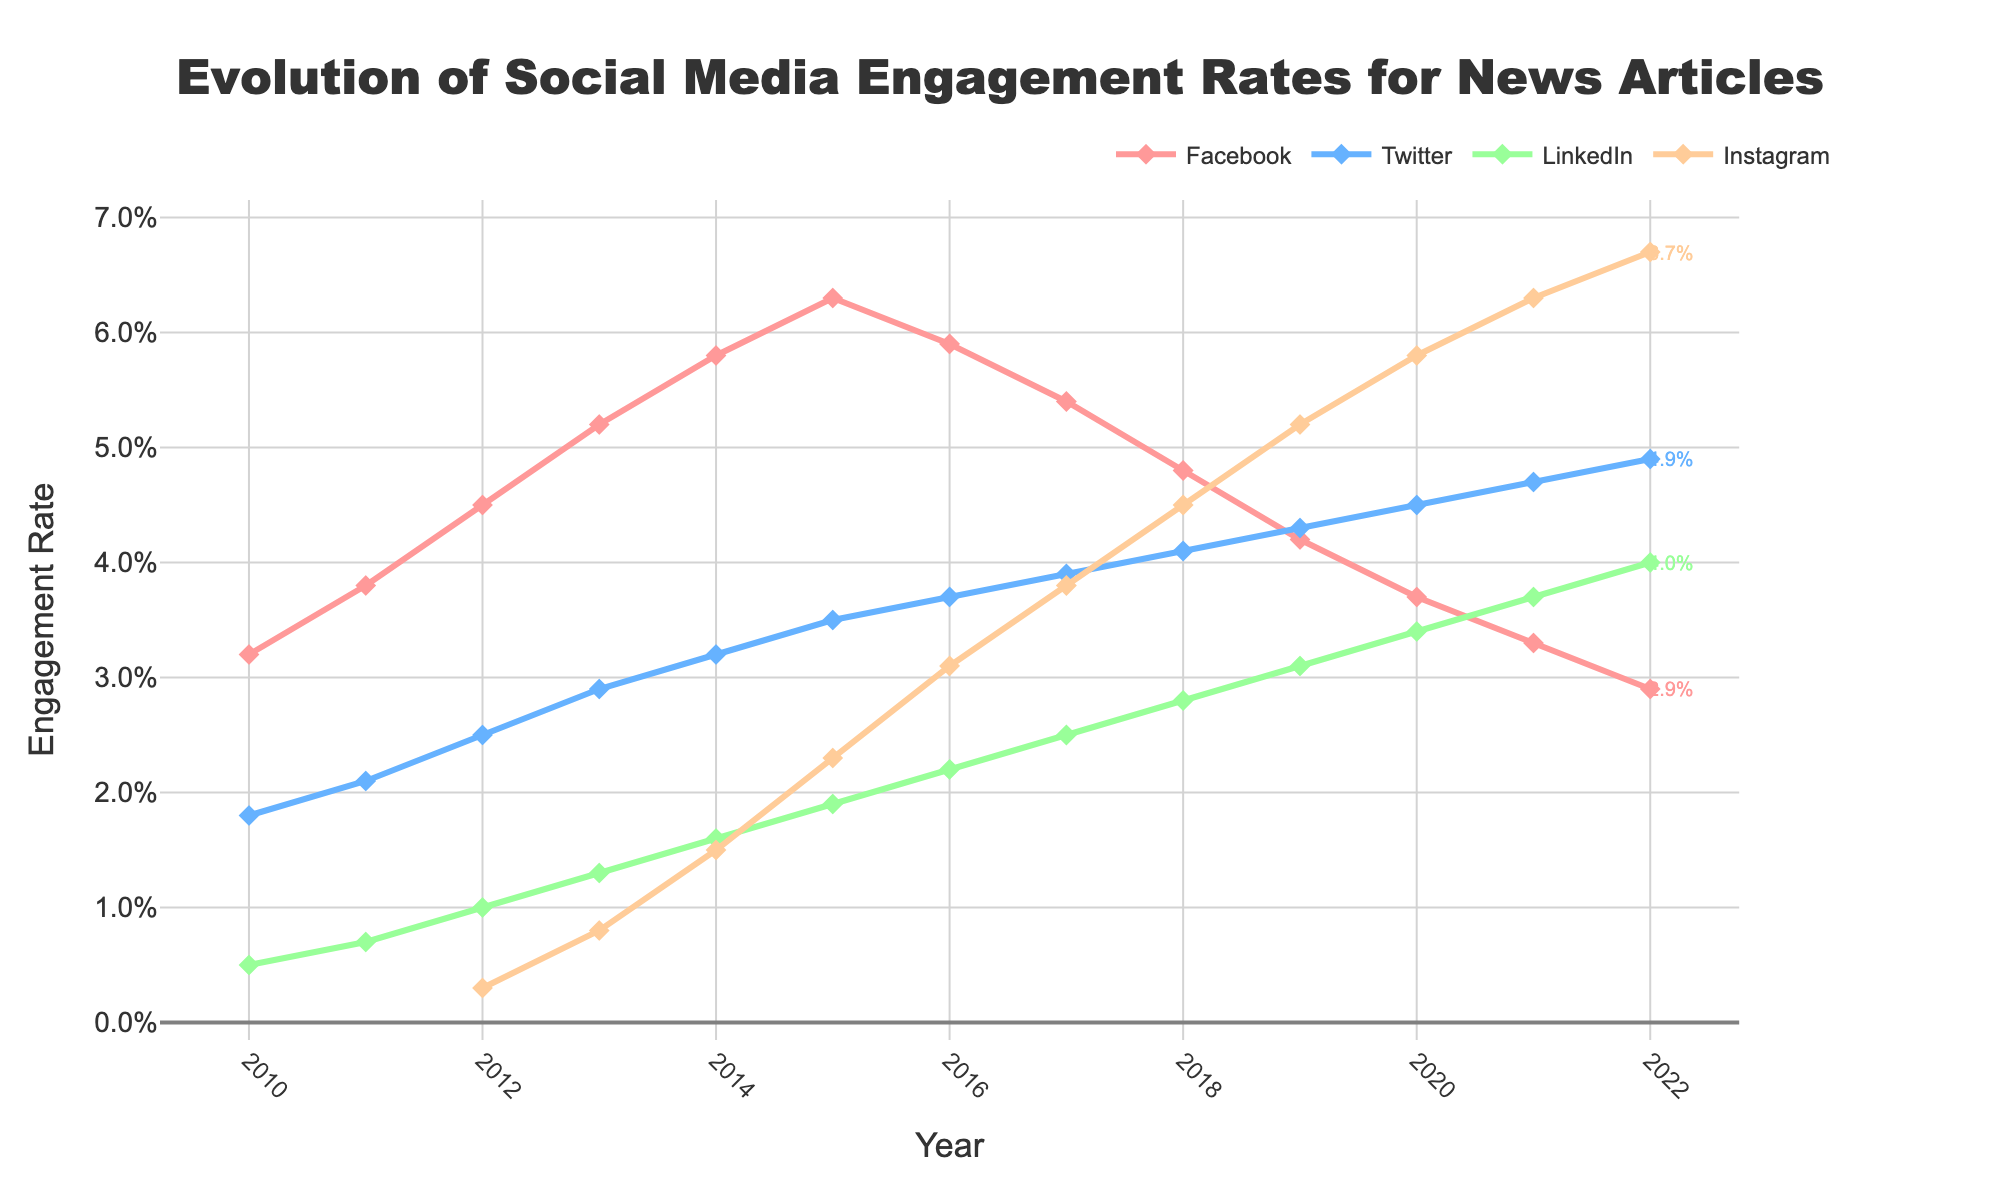Which platform had the highest engagement rate in 2022? Look at the engagement rates for all platforms in 2022. Instagram has the highest rate.
Answer: Instagram How did Facebook's engagement rate change from 2015 to 2022? Check the values for Facebook in 2015 and 2022. Subtract the value of 2022 from 2015 to find the difference. (6.3% in 2015 - 2.9% in 2022 = -3.4%)
Answer: Decreased by 3.4% What's the overall trend for Twitter's engagement rates from 2010 to 2022? Observe the line for Twitter from 2010 to 2022. The general pattern shows a steady increase each year.
Answer: Increasing In which year did LinkedIn's engagement rate surpass Facebook's for the first time? Compare LinkedIn's and Facebook's engagement rates year by year. In 2020, LinkedIn's rate (3.4%) was higher than Facebook's (3.7%).
Answer: 2021 Calculate the average engagement rate of Instagram from 2012 to 2022. Sum all Instagram engagement rates from 2012 to 2022, then divide by the number of years (11). (0.3 + 0.8 + 1.5 + 2.3 + 3.1 + 3.8 + 4.5 + 5.2 + 5.8 + 6.3 + 6.7) / 11 = 3.6%
Answer: 3.6% Which platform saw the largest increase in engagement rate from 2012 to 2022? Calculate the increase for each platform between 2012 and 2022, and find the largest. Instagram's increase was the highest from (0.3% to 6.7%, an increase of 6.4%).
Answer: Instagram Compare the engagement rates between Facebook and Instagram in 2018. Compare the specific values for both platforms in 2018. Facebook had 4.8% and Instagram had 4.5%.
Answer: Facebook was higher What is the trend seen in Facebook from 2016 to 2022? Examine the line for Facebook from 2016 to 2022. The pattern demonstrates a declining trend.
Answer: Declining Which year did Instagram's engagement rate exceed 5%? Look for the first year where Instagram's rate is above 5%. This occurred in 2019 with a value of 5.2%.
Answer: 2019 What is the difference in the engagement rate between LinkedIn and Twitter in 2022? Subtract LinkedIn's rate from Twitter's rate in 2022. (4.9% - 4.0% = 0.9%).
Answer: 0.9% 